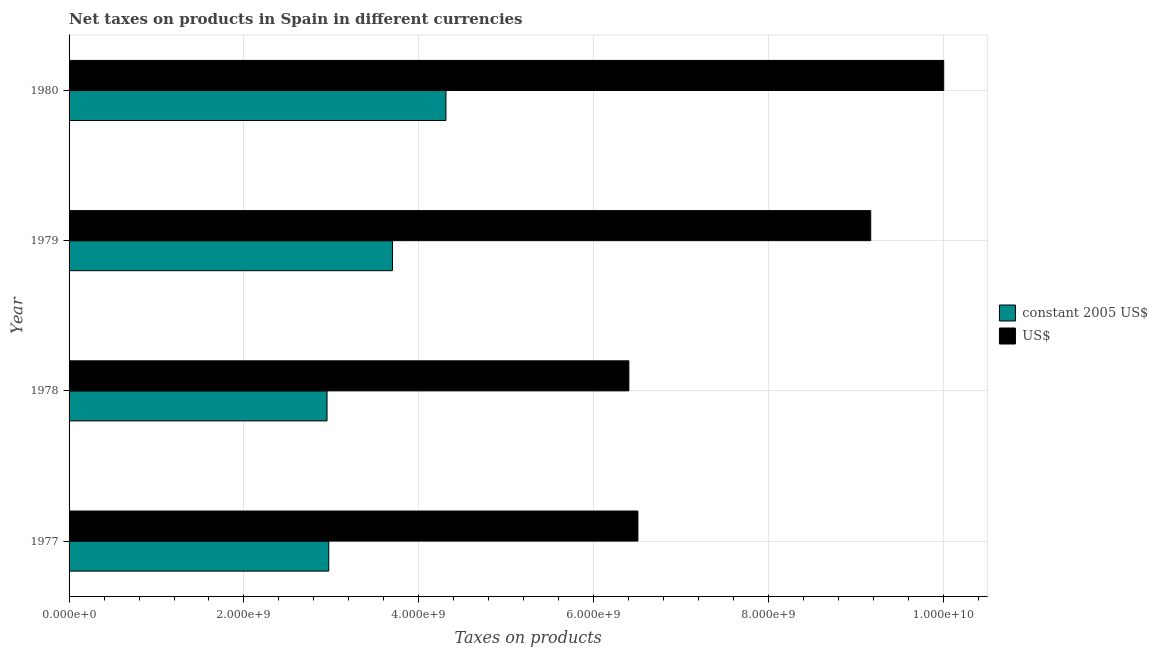How many groups of bars are there?
Give a very brief answer. 4. Are the number of bars per tick equal to the number of legend labels?
Your response must be concise. Yes. How many bars are there on the 2nd tick from the top?
Offer a very short reply. 2. How many bars are there on the 1st tick from the bottom?
Provide a short and direct response. 2. What is the label of the 4th group of bars from the top?
Make the answer very short. 1977. What is the net taxes in constant 2005 us$ in 1978?
Your answer should be compact. 2.95e+09. Across all years, what is the maximum net taxes in constant 2005 us$?
Your answer should be compact. 4.31e+09. Across all years, what is the minimum net taxes in constant 2005 us$?
Keep it short and to the point. 2.95e+09. In which year was the net taxes in us$ minimum?
Make the answer very short. 1978. What is the total net taxes in us$ in the graph?
Offer a very short reply. 3.21e+1. What is the difference between the net taxes in us$ in 1978 and that in 1980?
Offer a very short reply. -3.60e+09. What is the difference between the net taxes in us$ in 1977 and the net taxes in constant 2005 us$ in 1980?
Offer a terse response. 2.20e+09. What is the average net taxes in constant 2005 us$ per year?
Your answer should be very brief. 3.48e+09. In the year 1980, what is the difference between the net taxes in constant 2005 us$ and net taxes in us$?
Your response must be concise. -5.69e+09. What is the ratio of the net taxes in us$ in 1977 to that in 1980?
Your answer should be compact. 0.65. What is the difference between the highest and the second highest net taxes in us$?
Your response must be concise. 8.35e+08. What is the difference between the highest and the lowest net taxes in constant 2005 us$?
Keep it short and to the point. 1.36e+09. In how many years, is the net taxes in us$ greater than the average net taxes in us$ taken over all years?
Your answer should be very brief. 2. Is the sum of the net taxes in us$ in 1977 and 1980 greater than the maximum net taxes in constant 2005 us$ across all years?
Keep it short and to the point. Yes. What does the 2nd bar from the top in 1980 represents?
Give a very brief answer. Constant 2005 us$. What does the 2nd bar from the bottom in 1978 represents?
Your answer should be compact. US$. How many bars are there?
Offer a very short reply. 8. Are all the bars in the graph horizontal?
Provide a short and direct response. Yes. How many years are there in the graph?
Keep it short and to the point. 4. What is the difference between two consecutive major ticks on the X-axis?
Your answer should be compact. 2.00e+09. How many legend labels are there?
Your answer should be very brief. 2. What is the title of the graph?
Provide a succinct answer. Net taxes on products in Spain in different currencies. Does "Agricultural land" appear as one of the legend labels in the graph?
Give a very brief answer. No. What is the label or title of the X-axis?
Provide a succinct answer. Taxes on products. What is the Taxes on products in constant 2005 US$ in 1977?
Give a very brief answer. 2.97e+09. What is the Taxes on products in US$ in 1977?
Provide a short and direct response. 6.50e+09. What is the Taxes on products of constant 2005 US$ in 1978?
Give a very brief answer. 2.95e+09. What is the Taxes on products of US$ in 1978?
Give a very brief answer. 6.40e+09. What is the Taxes on products of constant 2005 US$ in 1979?
Offer a terse response. 3.70e+09. What is the Taxes on products of US$ in 1979?
Ensure brevity in your answer.  9.17e+09. What is the Taxes on products in constant 2005 US$ in 1980?
Offer a terse response. 4.31e+09. What is the Taxes on products of US$ in 1980?
Your answer should be compact. 1.00e+1. Across all years, what is the maximum Taxes on products of constant 2005 US$?
Offer a very short reply. 4.31e+09. Across all years, what is the maximum Taxes on products of US$?
Provide a short and direct response. 1.00e+1. Across all years, what is the minimum Taxes on products of constant 2005 US$?
Provide a succinct answer. 2.95e+09. Across all years, what is the minimum Taxes on products of US$?
Your answer should be very brief. 6.40e+09. What is the total Taxes on products of constant 2005 US$ in the graph?
Your answer should be compact. 1.39e+1. What is the total Taxes on products in US$ in the graph?
Give a very brief answer. 3.21e+1. What is the difference between the Taxes on products in constant 2005 US$ in 1977 and that in 1978?
Offer a terse response. 1.97e+07. What is the difference between the Taxes on products in US$ in 1977 and that in 1978?
Offer a terse response. 1.03e+08. What is the difference between the Taxes on products of constant 2005 US$ in 1977 and that in 1979?
Provide a succinct answer. -7.29e+08. What is the difference between the Taxes on products in US$ in 1977 and that in 1979?
Your answer should be very brief. -2.66e+09. What is the difference between the Taxes on products of constant 2005 US$ in 1977 and that in 1980?
Offer a very short reply. -1.34e+09. What is the difference between the Taxes on products in US$ in 1977 and that in 1980?
Your answer should be very brief. -3.50e+09. What is the difference between the Taxes on products of constant 2005 US$ in 1978 and that in 1979?
Your answer should be very brief. -7.48e+08. What is the difference between the Taxes on products of US$ in 1978 and that in 1979?
Give a very brief answer. -2.77e+09. What is the difference between the Taxes on products of constant 2005 US$ in 1978 and that in 1980?
Your response must be concise. -1.36e+09. What is the difference between the Taxes on products of US$ in 1978 and that in 1980?
Your answer should be very brief. -3.60e+09. What is the difference between the Taxes on products of constant 2005 US$ in 1979 and that in 1980?
Offer a very short reply. -6.12e+08. What is the difference between the Taxes on products in US$ in 1979 and that in 1980?
Your answer should be compact. -8.35e+08. What is the difference between the Taxes on products of constant 2005 US$ in 1977 and the Taxes on products of US$ in 1978?
Your answer should be compact. -3.43e+09. What is the difference between the Taxes on products of constant 2005 US$ in 1977 and the Taxes on products of US$ in 1979?
Your answer should be compact. -6.20e+09. What is the difference between the Taxes on products of constant 2005 US$ in 1977 and the Taxes on products of US$ in 1980?
Keep it short and to the point. -7.03e+09. What is the difference between the Taxes on products of constant 2005 US$ in 1978 and the Taxes on products of US$ in 1979?
Offer a very short reply. -6.22e+09. What is the difference between the Taxes on products in constant 2005 US$ in 1978 and the Taxes on products in US$ in 1980?
Offer a very short reply. -7.05e+09. What is the difference between the Taxes on products of constant 2005 US$ in 1979 and the Taxes on products of US$ in 1980?
Your answer should be compact. -6.30e+09. What is the average Taxes on products of constant 2005 US$ per year?
Offer a terse response. 3.48e+09. What is the average Taxes on products in US$ per year?
Your answer should be very brief. 8.02e+09. In the year 1977, what is the difference between the Taxes on products in constant 2005 US$ and Taxes on products in US$?
Give a very brief answer. -3.54e+09. In the year 1978, what is the difference between the Taxes on products of constant 2005 US$ and Taxes on products of US$?
Your answer should be compact. -3.45e+09. In the year 1979, what is the difference between the Taxes on products of constant 2005 US$ and Taxes on products of US$?
Your response must be concise. -5.47e+09. In the year 1980, what is the difference between the Taxes on products in constant 2005 US$ and Taxes on products in US$?
Offer a terse response. -5.69e+09. What is the ratio of the Taxes on products in US$ in 1977 to that in 1978?
Provide a short and direct response. 1.02. What is the ratio of the Taxes on products of constant 2005 US$ in 1977 to that in 1979?
Offer a terse response. 0.8. What is the ratio of the Taxes on products of US$ in 1977 to that in 1979?
Offer a terse response. 0.71. What is the ratio of the Taxes on products in constant 2005 US$ in 1977 to that in 1980?
Provide a succinct answer. 0.69. What is the ratio of the Taxes on products of US$ in 1977 to that in 1980?
Your answer should be very brief. 0.65. What is the ratio of the Taxes on products of constant 2005 US$ in 1978 to that in 1979?
Give a very brief answer. 0.8. What is the ratio of the Taxes on products in US$ in 1978 to that in 1979?
Keep it short and to the point. 0.7. What is the ratio of the Taxes on products of constant 2005 US$ in 1978 to that in 1980?
Your response must be concise. 0.68. What is the ratio of the Taxes on products of US$ in 1978 to that in 1980?
Keep it short and to the point. 0.64. What is the ratio of the Taxes on products in constant 2005 US$ in 1979 to that in 1980?
Provide a succinct answer. 0.86. What is the ratio of the Taxes on products in US$ in 1979 to that in 1980?
Your answer should be very brief. 0.92. What is the difference between the highest and the second highest Taxes on products of constant 2005 US$?
Keep it short and to the point. 6.12e+08. What is the difference between the highest and the second highest Taxes on products of US$?
Ensure brevity in your answer.  8.35e+08. What is the difference between the highest and the lowest Taxes on products of constant 2005 US$?
Your answer should be compact. 1.36e+09. What is the difference between the highest and the lowest Taxes on products in US$?
Ensure brevity in your answer.  3.60e+09. 